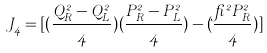<formula> <loc_0><loc_0><loc_500><loc_500>J _ { 4 } = [ ( \frac { Q _ { R } ^ { 2 } - Q _ { L } ^ { 2 } } { 4 } ) ( \frac { P _ { R } ^ { 2 } - P _ { L } ^ { 2 } } { 4 } ) - ( \frac { \beta ^ { 2 } P _ { R } ^ { 2 } } { 4 } ) ]</formula> 